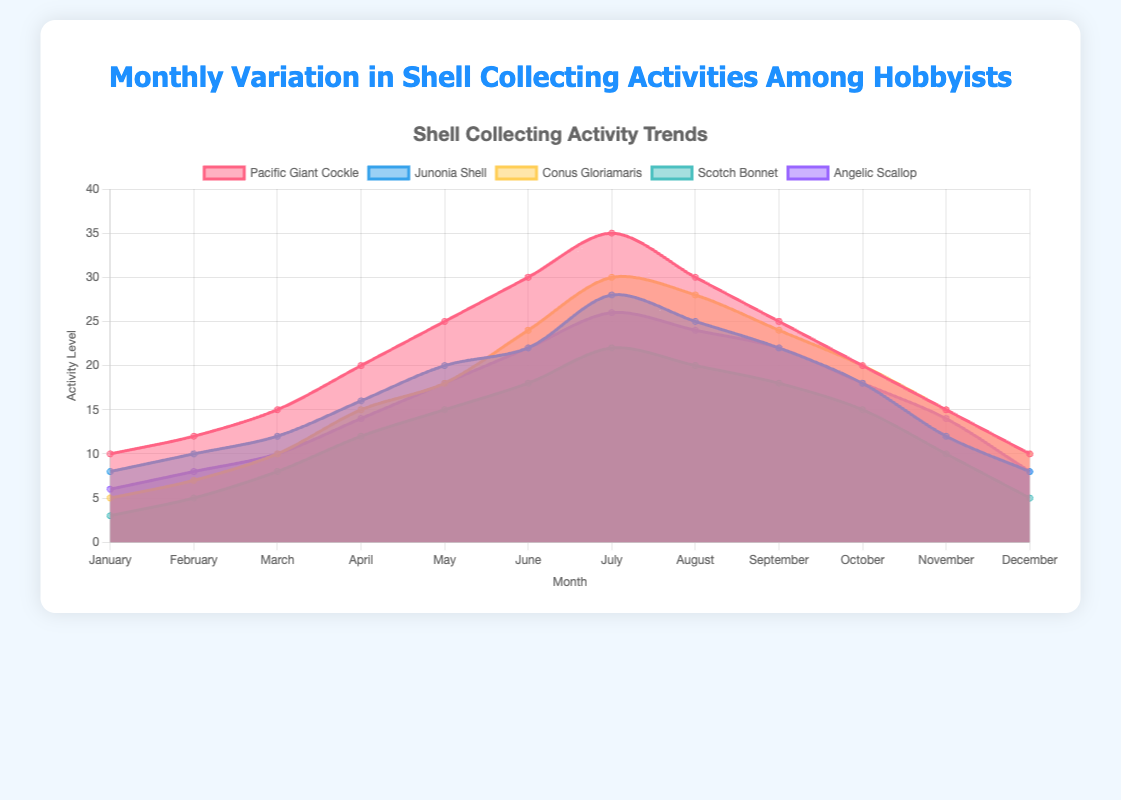What is the title of the chart? The title of the chart is displayed at the top and reads "Monthly Variation in Shell Collecting Activities Among Hobbyists".
Answer: Monthly Variation in Shell Collecting Activities Among Hobbyists During which month is the activity for the Pacific Giant Cockle the highest? The highest activity level for the Pacific Giant Cockle is in July, where the data value reaches 35.
Answer: July Compare the activity levels of Scotch Bonnet and Angelic Scallop in April. Which one is higher and by how much? In April, the activity level of Scotch Bonnet is 12, and that of Angelic Scallop is 14. The Angelic Scallop's activity level is higher by a difference of 14 - 12 = 2.
Answer: Angelic Scallop, by 2 Which shell shows the least variation in its activity levels throughout the year? To determine the least variation, look at the ranges for each shell. The Scotch Bonnet varies from 3 to 22, which is the smallest range compared to others.
Answer: Scotch Bonnet What is the average activity level for Junonia Shell from June to August? The activity levels for Junonia Shell from June to August are 22, 28, and 25. The sum of these is 22 + 28 + 25 = 75, and the average (mean) is 75/3 = 25.
Answer: 25 Which month has the highest overall shell collecting activity combined across all five types of shells? First, sum the data values for all five shells in each month. The highest sum is found in July: Pacific Giant Cockle (35) + Junonia Shell (28) + Conus Gloriamaris (30) + Scotch Bonnet (22) + Angelic Scallop (26) = 141.
Answer: July How does the trend for Conus Gloriamaris compare across the year? The activity trend for Conus Gloriamaris increases from January (5) to a peak in July (30) and then decreases back to December (10), showing a symmetric pattern.
Answer: Symmetrical increase and decrease What month shows the peak activity for the majority of shells? By observing the highest points for the majority of shells, most of them peak in July: Pacific Giant Cockle (35), Conus Gloriamaris (30), and Angelic Scallop (26) all peak in July, as does Junonia Shell (28). Scotch Bonnet has its peak in July (22), but it peaks just below the others, confirming July is the dominant peak month.
Answer: July What is the total activity level for all shells in May? The total activity level for all shells in May is the sum of data points for May: Pacific Giant Cockle (25) + Junonia Shell (20) + Conus Gloriamaris (18) + Scotch Bonnet (15) + Angelic Scallop (18) = 96.
Answer: 96 Which shell type has the highest increase in activity from January to July? Calculate the difference for each shell type from January to July. For the Pacific Giant Cockle: 35 - 10 = 25, Junonia Shell: 28 - 8 = 20, Conus Gloriamaris: 30 - 5 = 25, Scotch Bonnet: 22 - 3 = 19, Angelic Scallop: 26 - 6 = 20. Both Pacific Giant Cockle and Conus Gloriamaris share the highest increase of 25.
Answer: Pacific Giant Cockle and Conus Gloriamaris 